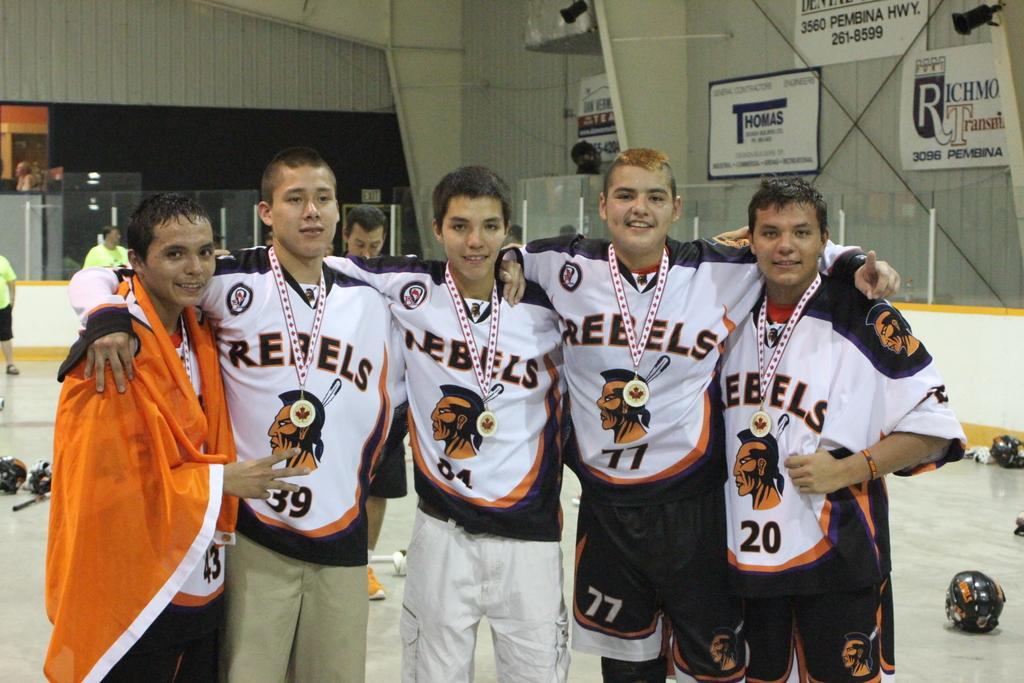<image>
Provide a brief description of the given image. Several boys in Rebels jerseys have medals around their necks. 